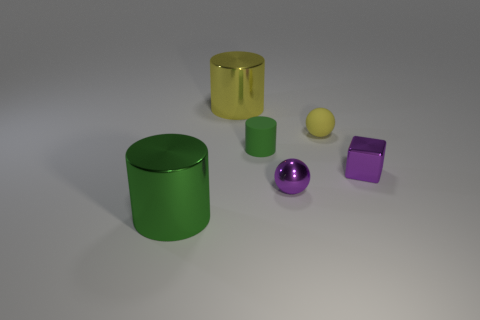There is a shiny object that is the same size as the yellow cylinder; what is its color?
Keep it short and to the point. Green. Is the number of things that are behind the purple block greater than the number of big shiny objects?
Offer a terse response. Yes. The cylinder that is both in front of the large yellow cylinder and behind the green shiny thing is made of what material?
Your answer should be compact. Rubber. Does the small matte object that is in front of the yellow matte object have the same color as the cylinder that is on the left side of the large yellow object?
Provide a succinct answer. Yes. How many other things are there of the same size as the yellow metallic object?
Keep it short and to the point. 1. Is there a purple thing in front of the large metal object in front of the metallic object that is behind the tiny purple cube?
Your answer should be very brief. No. Does the green thing on the left side of the tiny green rubber thing have the same material as the yellow sphere?
Your response must be concise. No. What is the color of the other metal thing that is the same shape as the small yellow object?
Provide a short and direct response. Purple. Is there anything else that is the same shape as the big green thing?
Ensure brevity in your answer.  Yes. Are there an equal number of purple shiny blocks that are on the left side of the big yellow cylinder and blue things?
Your answer should be very brief. Yes. 